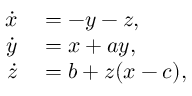<formula> <loc_0><loc_0><loc_500><loc_500>\begin{array} { r l } { \dot { x } } & = - y - z , } \\ { \dot { y } } & = x + a y , } \\ { \dot { z } } & = b + z ( x - c ) , } \end{array}</formula> 